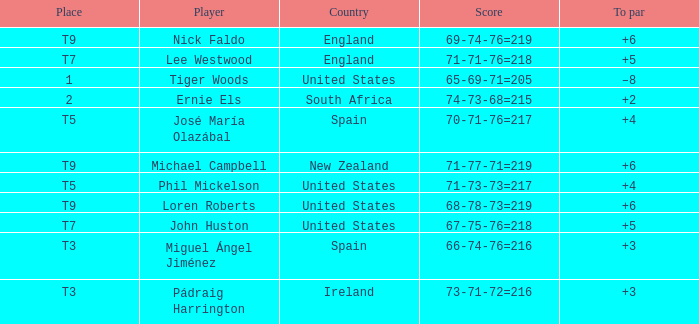What is Player, when Place is "1"? Tiger Woods. 